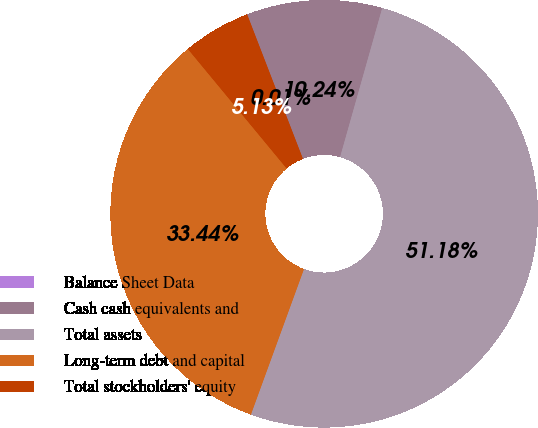Convert chart. <chart><loc_0><loc_0><loc_500><loc_500><pie_chart><fcel>Balance Sheet Data<fcel>Cash cash equivalents and<fcel>Total assets<fcel>Long-term debt and capital<fcel>Total stockholders' equity<nl><fcel>0.01%<fcel>10.24%<fcel>51.18%<fcel>33.44%<fcel>5.13%<nl></chart> 